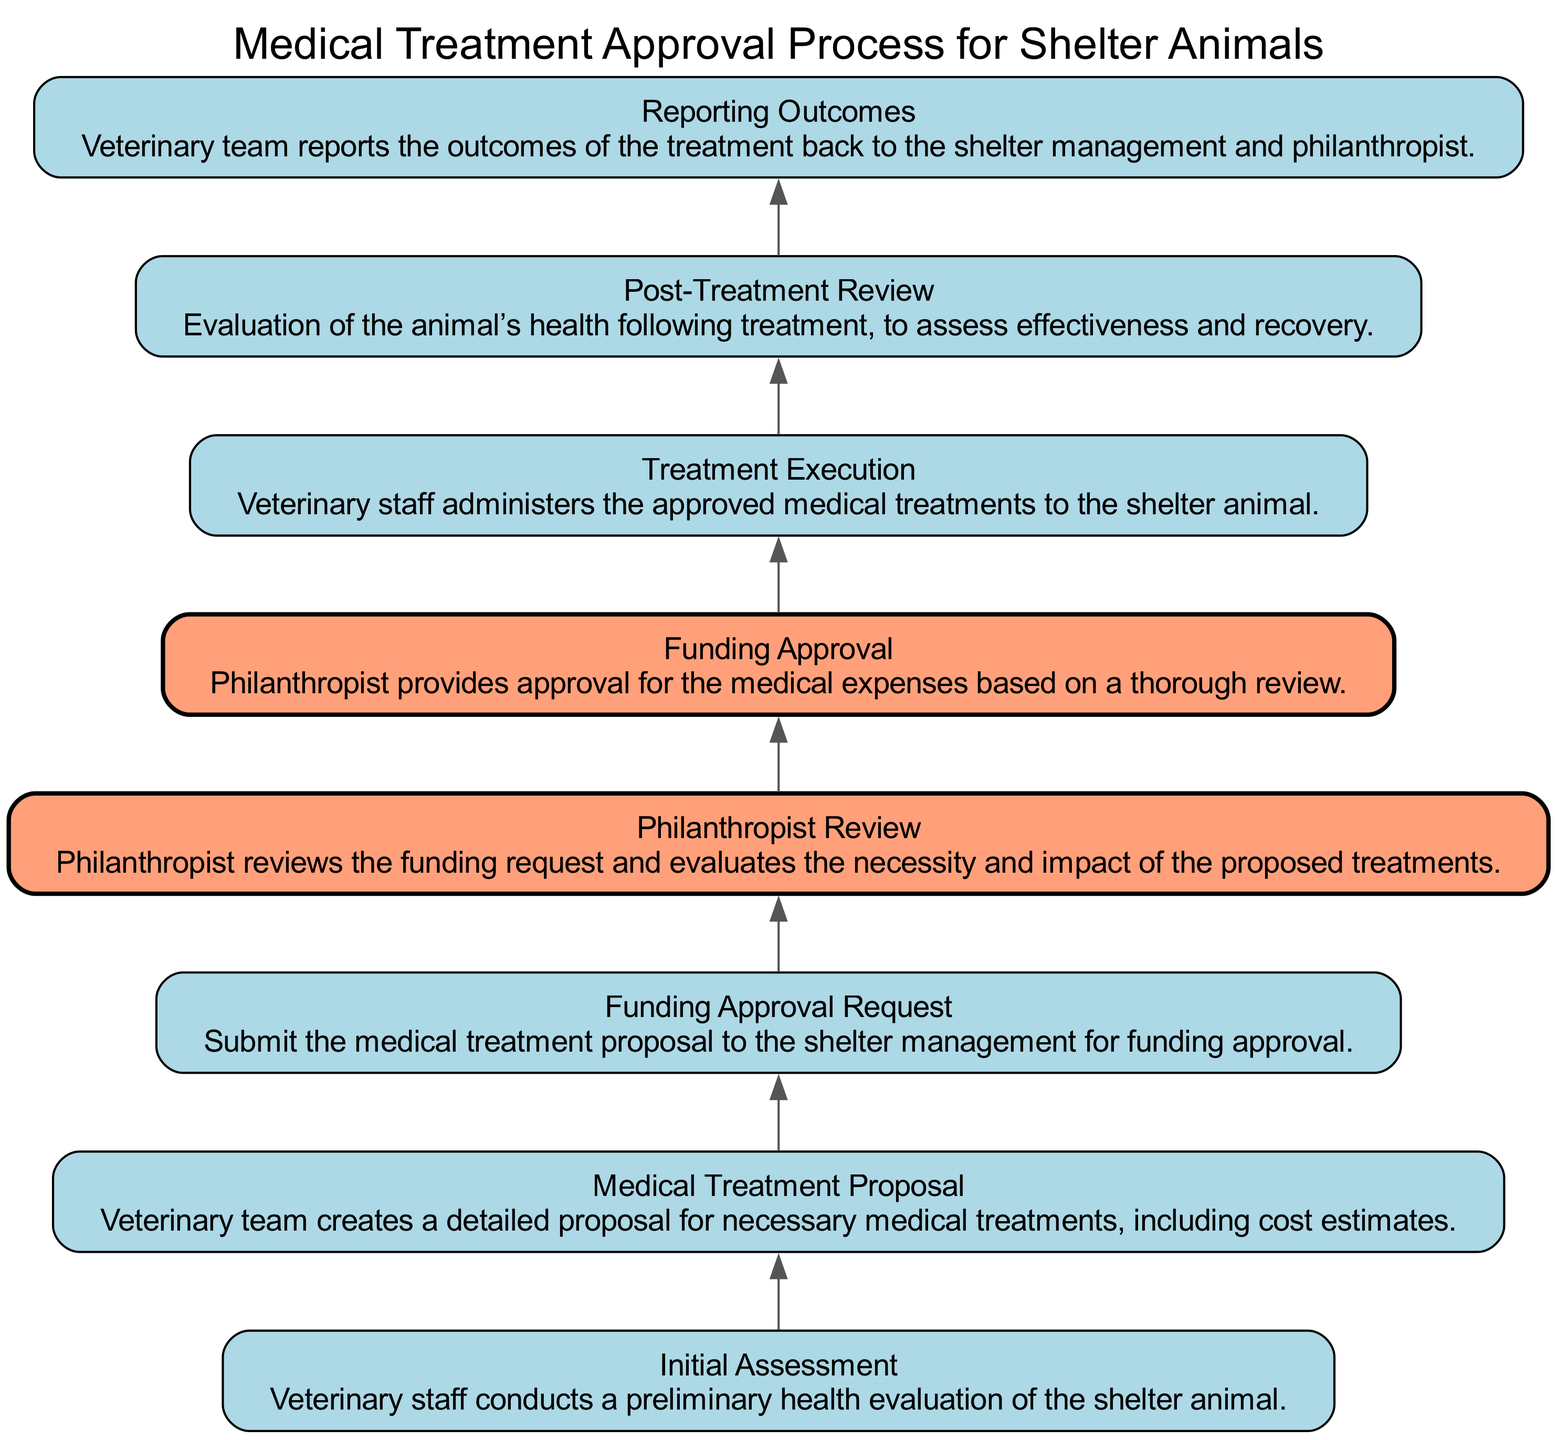What is the first step in the medical treatment approval process? The first step is "Initial Assessment," where veterinary staff conducts a preliminary health evaluation of the shelter animal.
Answer: Initial Assessment How many total steps are there in the approval process? There are eight steps in the medical treatment approval process, as indicated by the eight distinct nodes in the diagram.
Answer: Eight Which node follows the "Funding Approval Request"? The node that follows "Funding Approval Request" is "Philanthropist Review," which is where the philanthropist reviews the funding request for necessary medical treatments.
Answer: Philanthropist Review What is the name of the last step in the process? The last step in the process is named "Reporting Outcomes," where the veterinary team reports the outcomes back to shelter management and the philanthropist.
Answer: Reporting Outcomes Which step is highlighted to indicate the involvement of a philanthropist? The steps highlighted to indicate the involvement of a philanthropist are "Philanthropist Review" and "Funding Approval." These steps are shown with a different fill color.
Answer: Philanthropist Review and Funding Approval After which step does the "Treatment Execution" occur? "Treatment Execution" occurs after "Funding Approval," indicating that treatments are administered only after receiving funding approval from the philanthropist.
Answer: Funding Approval What step involves the evaluation of the animal’s health post-treatment? The step that involves the evaluation of the animal’s health post-treatment is "Post-Treatment Review." This step assesses the effectiveness and recovery of the animal after treatments are administered.
Answer: Post-Treatment Review Which two steps are connected directly without any intermediate steps? The two steps directly connected without any intermediate steps are "Funding Approval" and "Treatment Execution." The connection shows that funding approval leads directly to the execution of the approved treatments.
Answer: Funding Approval and Treatment Execution 